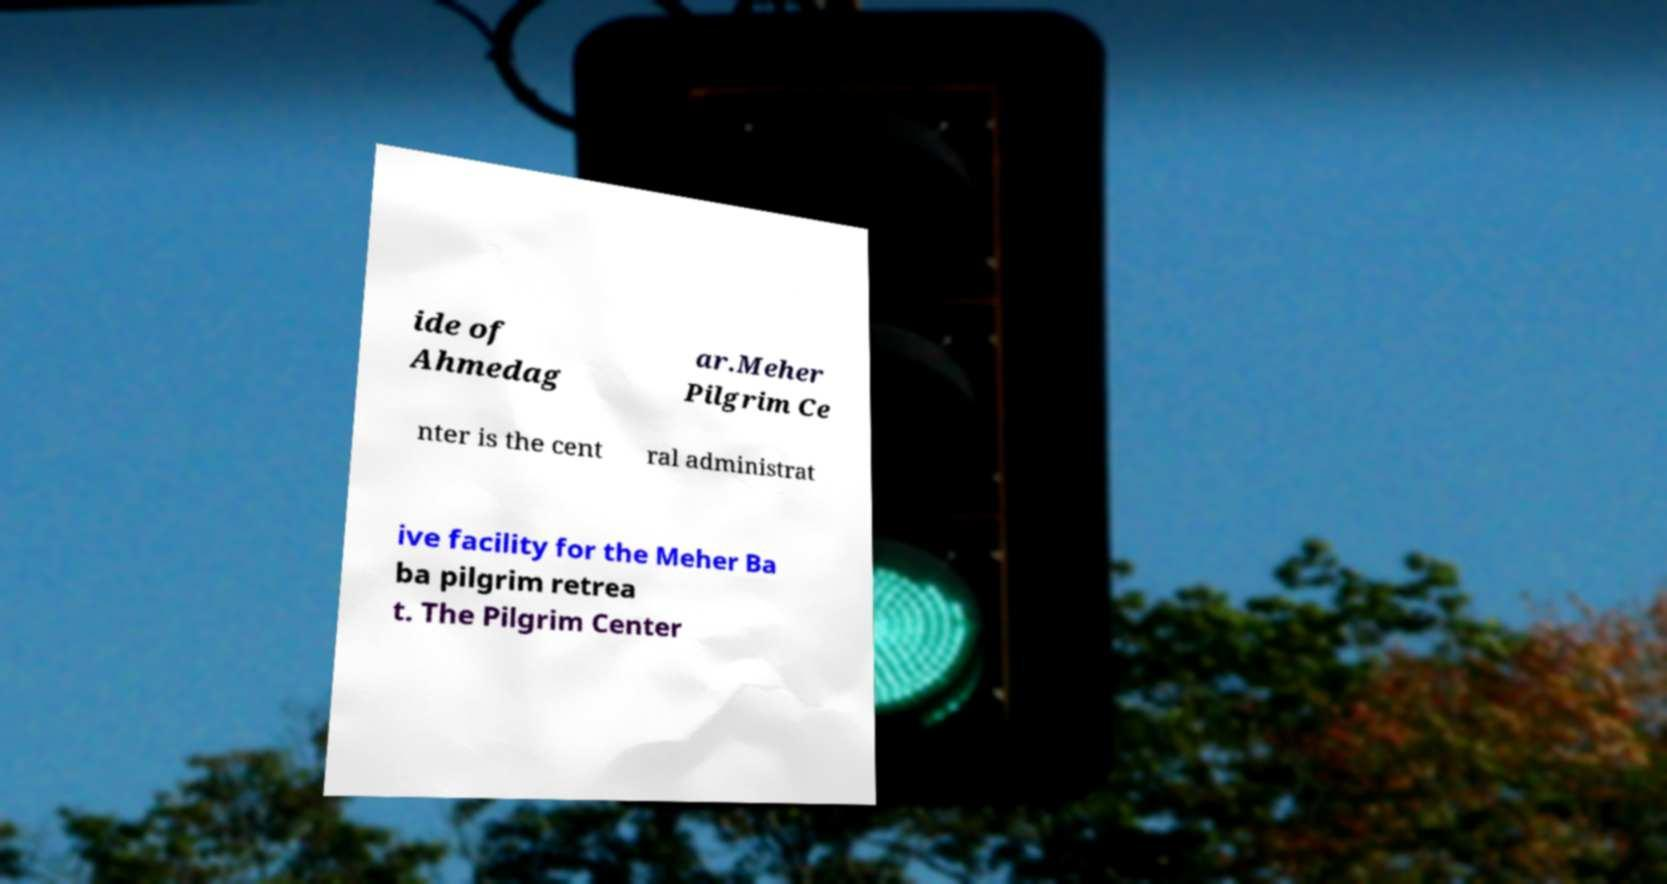What messages or text are displayed in this image? I need them in a readable, typed format. ide of Ahmedag ar.Meher Pilgrim Ce nter is the cent ral administrat ive facility for the Meher Ba ba pilgrim retrea t. The Pilgrim Center 